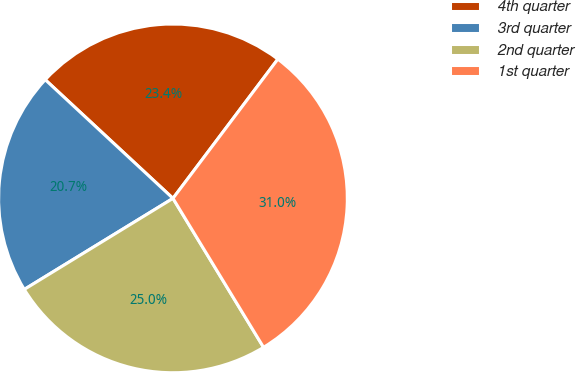Convert chart to OTSL. <chart><loc_0><loc_0><loc_500><loc_500><pie_chart><fcel>4th quarter<fcel>3rd quarter<fcel>2nd quarter<fcel>1st quarter<nl><fcel>23.36%<fcel>20.66%<fcel>24.95%<fcel>31.03%<nl></chart> 